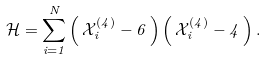<formula> <loc_0><loc_0><loc_500><loc_500>\mathcal { H } = \sum _ { i = 1 } ^ { N } \left ( \, { \mathcal { X } } _ { i } ^ { ( 4 ) } - 6 \, \right ) \left ( \, { \mathcal { X } } _ { i } ^ { ( 4 ) } - 4 \, \right ) .</formula> 